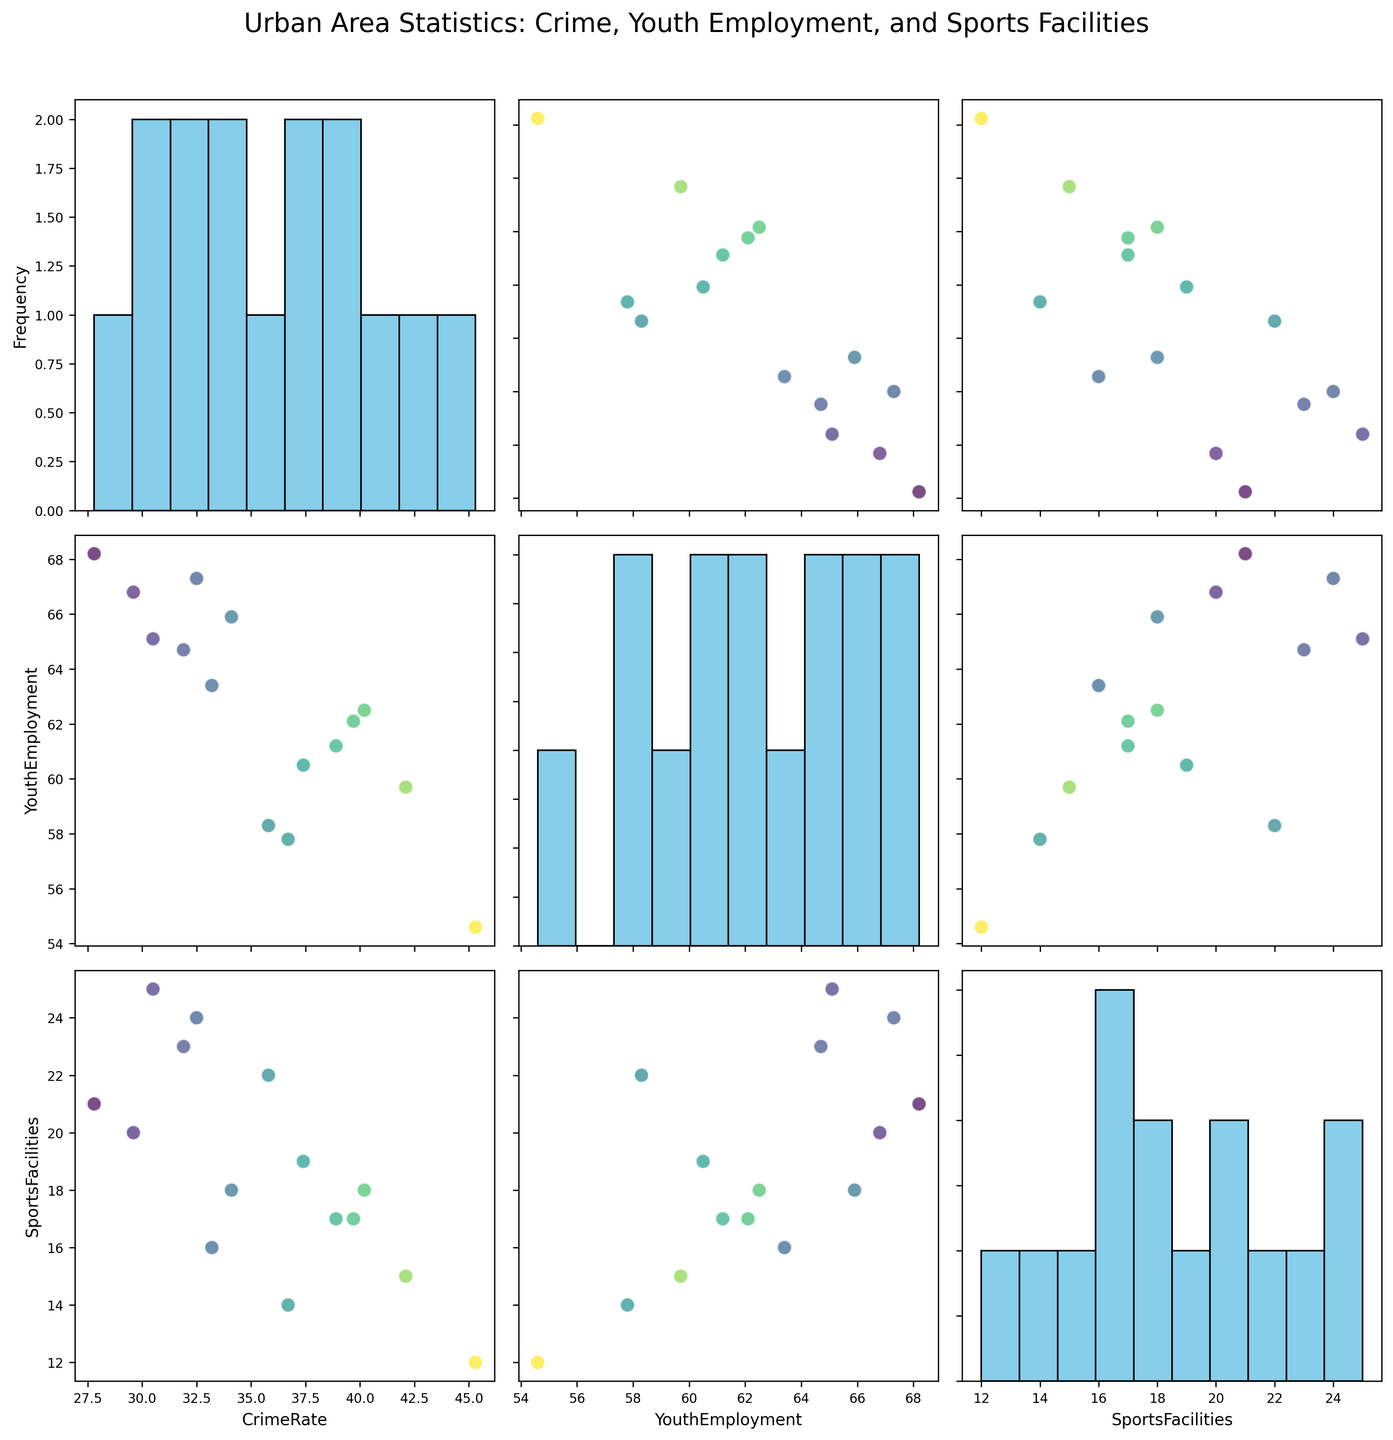What is the title of the figure? The title is typically displayed at the top center of the figure. Reading from the figure, the title is "Urban Area Statistics: Crime, Youth Employment, and Sports Facilities."
Answer: Urban Area Statistics: Crime, Youth Employment, and Sports Facilities How many cities are represented in the scatterplot matrix? Count the number of data points (each representing a city) in any scatterplot within the matrix. Each plot shows 15 data points.
Answer: 15 Which city has the highest crime rate? Look for the maximum value in any plot where Crime Rate is the y-axis and identify the corresponding city. Detroit has the highest crime rate of 45.3.
Answer: Detroit Which city has the most sports facilities? Identify the city that aligns with the maximum value on the Sports Facilities axis in any plot. New York has the most sports facilities with 25.
Answer: New York Is there a noticeable correlation between Crime Rate and Sports Facilities? Examine the scatter plot where Crime Rate is on one axis and Sports Facilities on the other. The points do not show a clear trend, indicating no strong correlation.
Answer: No Which two cities have similar features in terms of youth employment and sports facilities? Find two data points that are close to each other in the scatter plot between Youth Employment and Sports Facilities axes. San Jose and Seattle are close to each other, with San Jose having 68.2 and 21, and Seattle having 67.3 and 24, respectively.
Answer: San Jose and Seattle What is the range of crime rates observed in the figure? Identify the minimum and maximum Crime Rate values by looking at any plot that has Crime Rate on the axis. The range is from 27.8 (San Jose) to 45.3 (Detroit).
Answer: 27.8 to 45.3 Which city has the highest youth employment rate and how does its sports facility availability compare to the city with the lowest crime rate? Identify the city with the highest youth employment rate (San Jose, 68.2) and compare its sports facilities (21) to the city with the lowest crime rate (San Jose, 27.8 and 21). Both the highest youth employment rate and the lowest crime rate belong to San Jose, which has 21 sports facilities.
Answer: San Jose has 21 sports facilities; it's the same city in both respects How does Denver's crime rate compare to Boston's? Find and compare the y-axis value (Crime Rate) for Denver and Boston in any relevant scatter or on the histogram. Denver (34.1) has a lower crime rate than Boston (31.9).
Answer: Denver has a higher crime rate than Boston Does higher youth employment generally indicate more sports facilities? Compare the scatter plots between Youth Employment and Sports Facilities. There seems to be a positive trend, indicating higher youth employment generally corresponds to more sports facilities.
Answer: Yes 